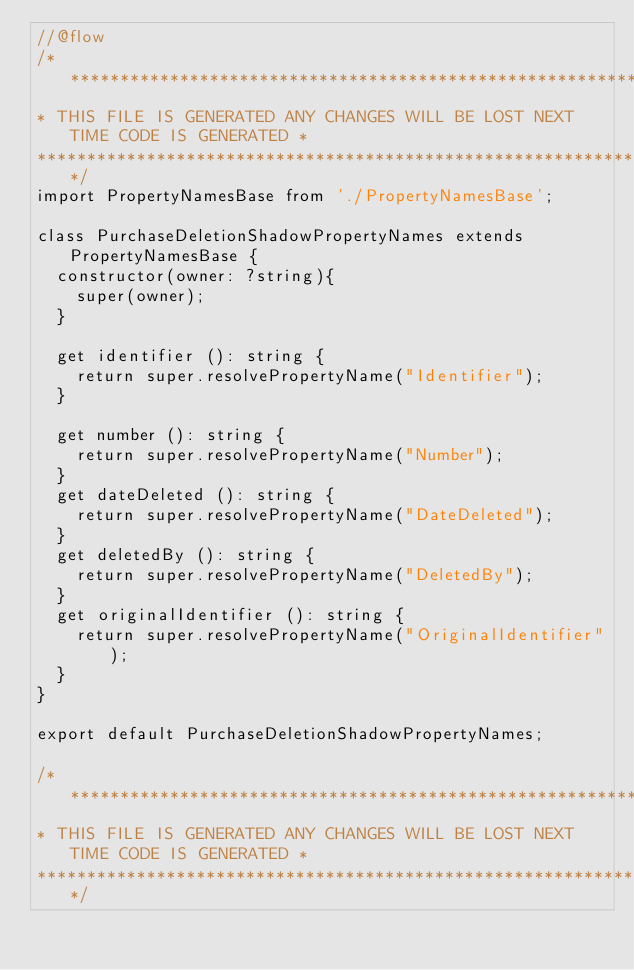<code> <loc_0><loc_0><loc_500><loc_500><_JavaScript_>//@flow
/******************************************************************************
* THIS FILE IS GENERATED ANY CHANGES WILL BE LOST NEXT TIME CODE IS GENERATED *
******************************************************************************/
import PropertyNamesBase from './PropertyNamesBase';

class PurchaseDeletionShadowPropertyNames extends PropertyNamesBase {
  constructor(owner: ?string){
    super(owner);
  }

  get identifier (): string {
    return super.resolvePropertyName("Identifier");
  }

  get number (): string {
    return super.resolvePropertyName("Number");
  }
  get dateDeleted (): string {
    return super.resolvePropertyName("DateDeleted");
  }
  get deletedBy (): string {
    return super.resolvePropertyName("DeletedBy");
  }
  get originalIdentifier (): string {
    return super.resolvePropertyName("OriginalIdentifier");
  }
}

export default PurchaseDeletionShadowPropertyNames;

/******************************************************************************
* THIS FILE IS GENERATED ANY CHANGES WILL BE LOST NEXT TIME CODE IS GENERATED *
******************************************************************************/
</code> 